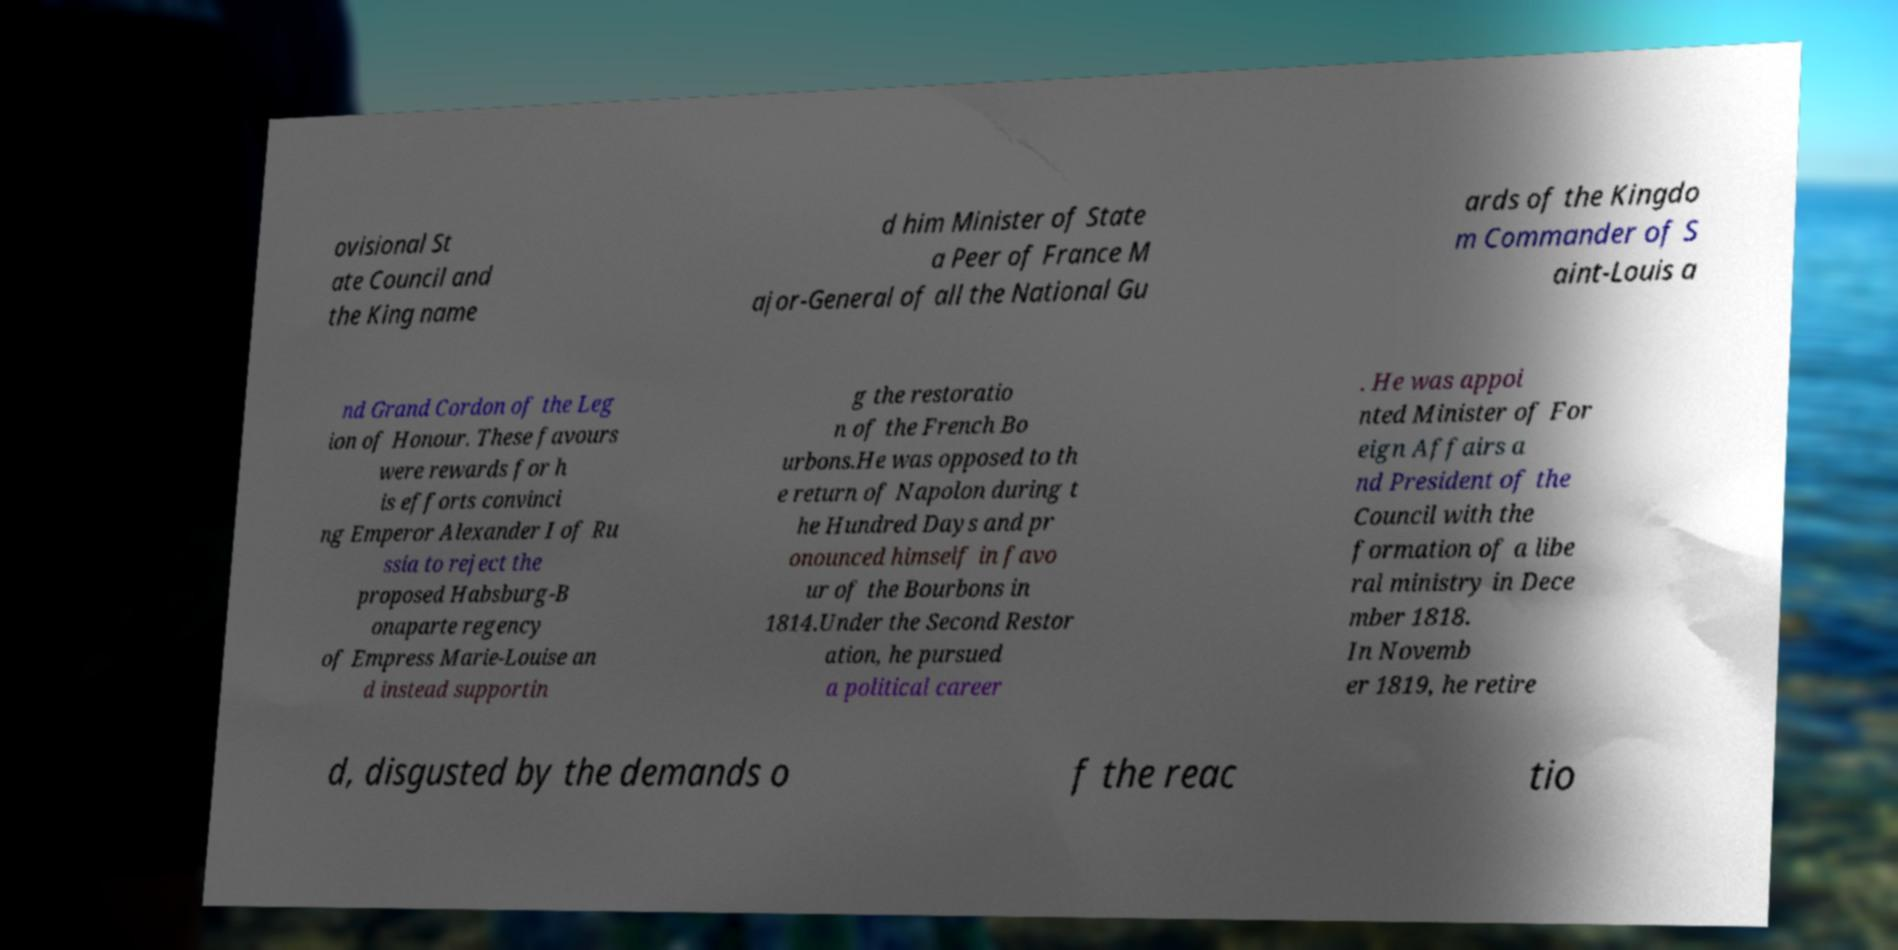Please read and relay the text visible in this image. What does it say? ovisional St ate Council and the King name d him Minister of State a Peer of France M ajor-General of all the National Gu ards of the Kingdo m Commander of S aint-Louis a nd Grand Cordon of the Leg ion of Honour. These favours were rewards for h is efforts convinci ng Emperor Alexander I of Ru ssia to reject the proposed Habsburg-B onaparte regency of Empress Marie-Louise an d instead supportin g the restoratio n of the French Bo urbons.He was opposed to th e return of Napolon during t he Hundred Days and pr onounced himself in favo ur of the Bourbons in 1814.Under the Second Restor ation, he pursued a political career . He was appoi nted Minister of For eign Affairs a nd President of the Council with the formation of a libe ral ministry in Dece mber 1818. In Novemb er 1819, he retire d, disgusted by the demands o f the reac tio 